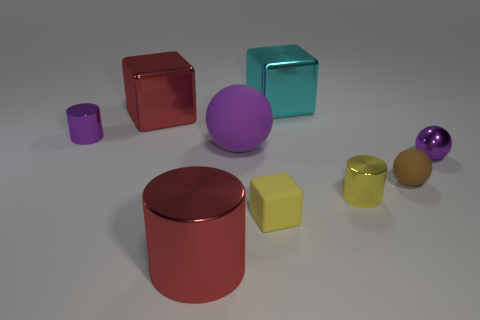There is a yellow shiny thing that is the same size as the brown sphere; what is its shape?
Ensure brevity in your answer.  Cylinder. Is there another tiny matte thing of the same shape as the yellow rubber object?
Give a very brief answer. No. What shape is the red object in front of the cylinder that is behind the purple shiny sphere?
Offer a very short reply. Cylinder. There is a large cyan object; what shape is it?
Provide a short and direct response. Cube. There is a purple thing that is right of the small metallic cylinder to the right of the red object that is in front of the yellow block; what is it made of?
Provide a short and direct response. Metal. What number of other things are the same material as the yellow cylinder?
Provide a succinct answer. 5. How many small brown objects are on the right side of the tiny brown matte sphere in front of the purple rubber object?
Offer a terse response. 0. How many cylinders are either large green objects or tiny yellow shiny things?
Your response must be concise. 1. The large thing that is behind the tiny brown rubber object and in front of the red shiny cube is what color?
Offer a terse response. Purple. Is there any other thing of the same color as the large cylinder?
Make the answer very short. Yes. 